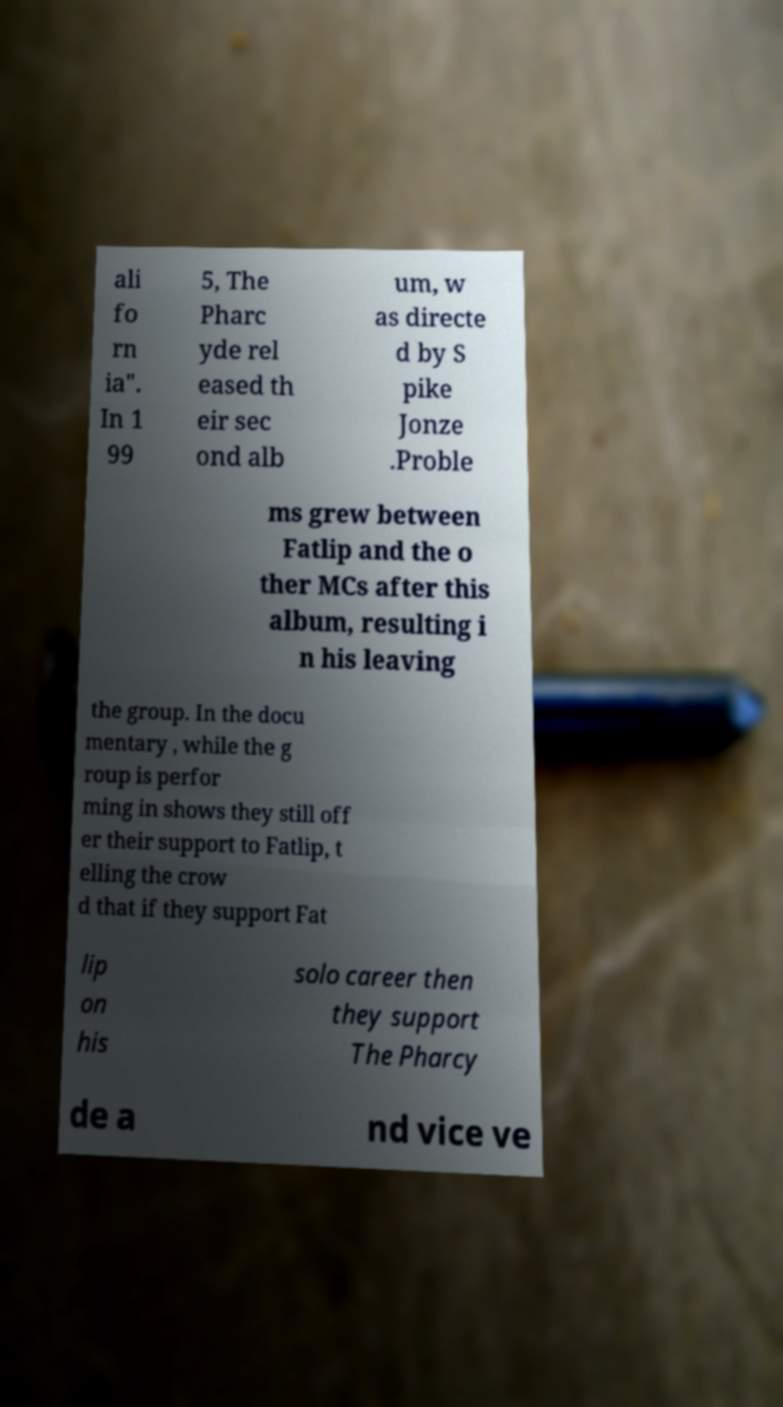I need the written content from this picture converted into text. Can you do that? ali fo rn ia". In 1 99 5, The Pharc yde rel eased th eir sec ond alb um, w as directe d by S pike Jonze .Proble ms grew between Fatlip and the o ther MCs after this album, resulting i n his leaving the group. In the docu mentary , while the g roup is perfor ming in shows they still off er their support to Fatlip, t elling the crow d that if they support Fat lip on his solo career then they support The Pharcy de a nd vice ve 